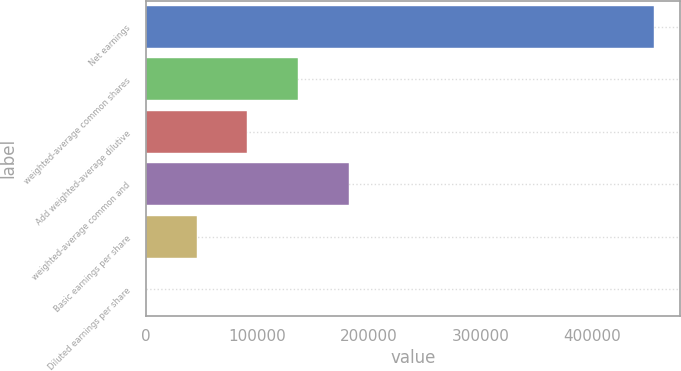Convert chart. <chart><loc_0><loc_0><loc_500><loc_500><bar_chart><fcel>Net earnings<fcel>weighted-average common shares<fcel>Add weighted-average dilutive<fcel>weighted-average common and<fcel>Basic earnings per share<fcel>Diluted earnings per share<nl><fcel>455833<fcel>136755<fcel>91172<fcel>182337<fcel>45589.3<fcel>6.7<nl></chart> 